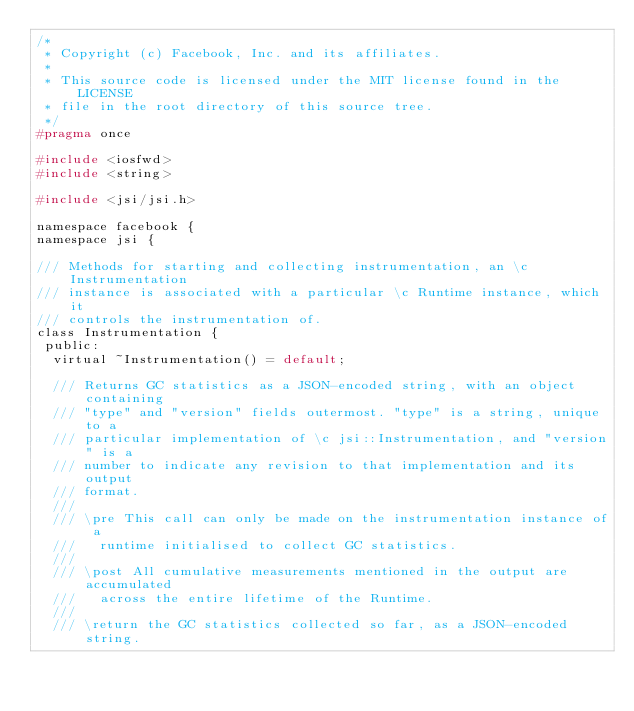Convert code to text. <code><loc_0><loc_0><loc_500><loc_500><_C_>/*
 * Copyright (c) Facebook, Inc. and its affiliates.
 *
 * This source code is licensed under the MIT license found in the LICENSE
 * file in the root directory of this source tree.
 */
#pragma once

#include <iosfwd>
#include <string>

#include <jsi/jsi.h>

namespace facebook {
namespace jsi {

/// Methods for starting and collecting instrumentation, an \c Instrumentation
/// instance is associated with a particular \c Runtime instance, which it
/// controls the instrumentation of.
class Instrumentation {
 public:
  virtual ~Instrumentation() = default;

  /// Returns GC statistics as a JSON-encoded string, with an object containing
  /// "type" and "version" fields outermost. "type" is a string, unique to a
  /// particular implementation of \c jsi::Instrumentation, and "version" is a
  /// number to indicate any revision to that implementation and its output
  /// format.
  ///
  /// \pre This call can only be made on the instrumentation instance of a
  ///   runtime initialised to collect GC statistics.
  ///
  /// \post All cumulative measurements mentioned in the output are accumulated
  ///   across the entire lifetime of the Runtime.
  ///
  /// \return the GC statistics collected so far, as a JSON-encoded string.</code> 